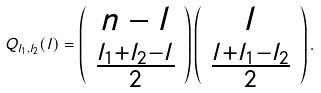Convert formula to latex. <formula><loc_0><loc_0><loc_500><loc_500>Q _ { l _ { 1 } , l _ { 2 } } ( l ) = \left ( \begin{array} { c } n - l \\ \frac { l _ { 1 } + l _ { 2 } - l } { 2 } \end{array} \right ) \left ( \begin{array} { c } l \\ \frac { l + l _ { 1 } - l _ { 2 } } { 2 } \end{array} \right ) .</formula> 